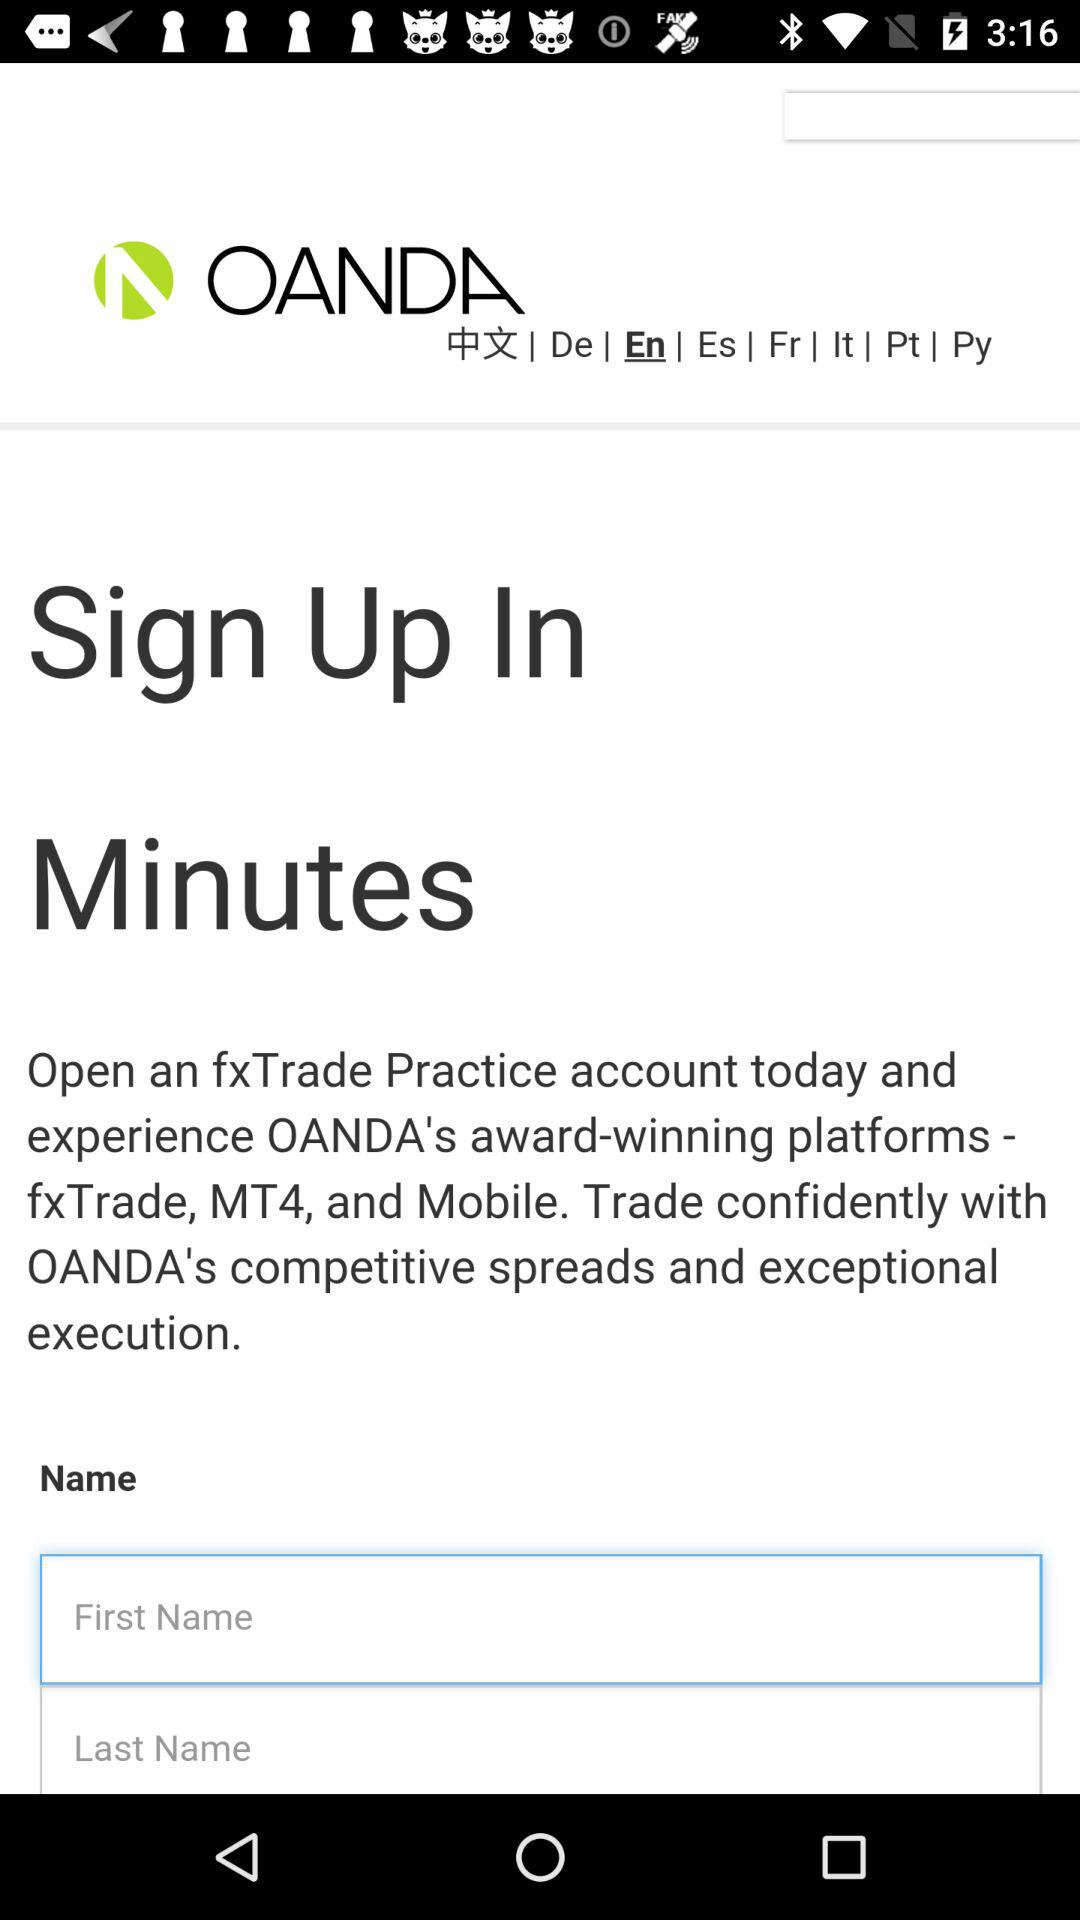How many languages are supported by OANDA?
Answer the question using a single word or phrase. 8 